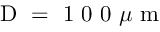Convert formula to latex. <formula><loc_0><loc_0><loc_500><loc_500>D = 1 0 0 \mu m</formula> 